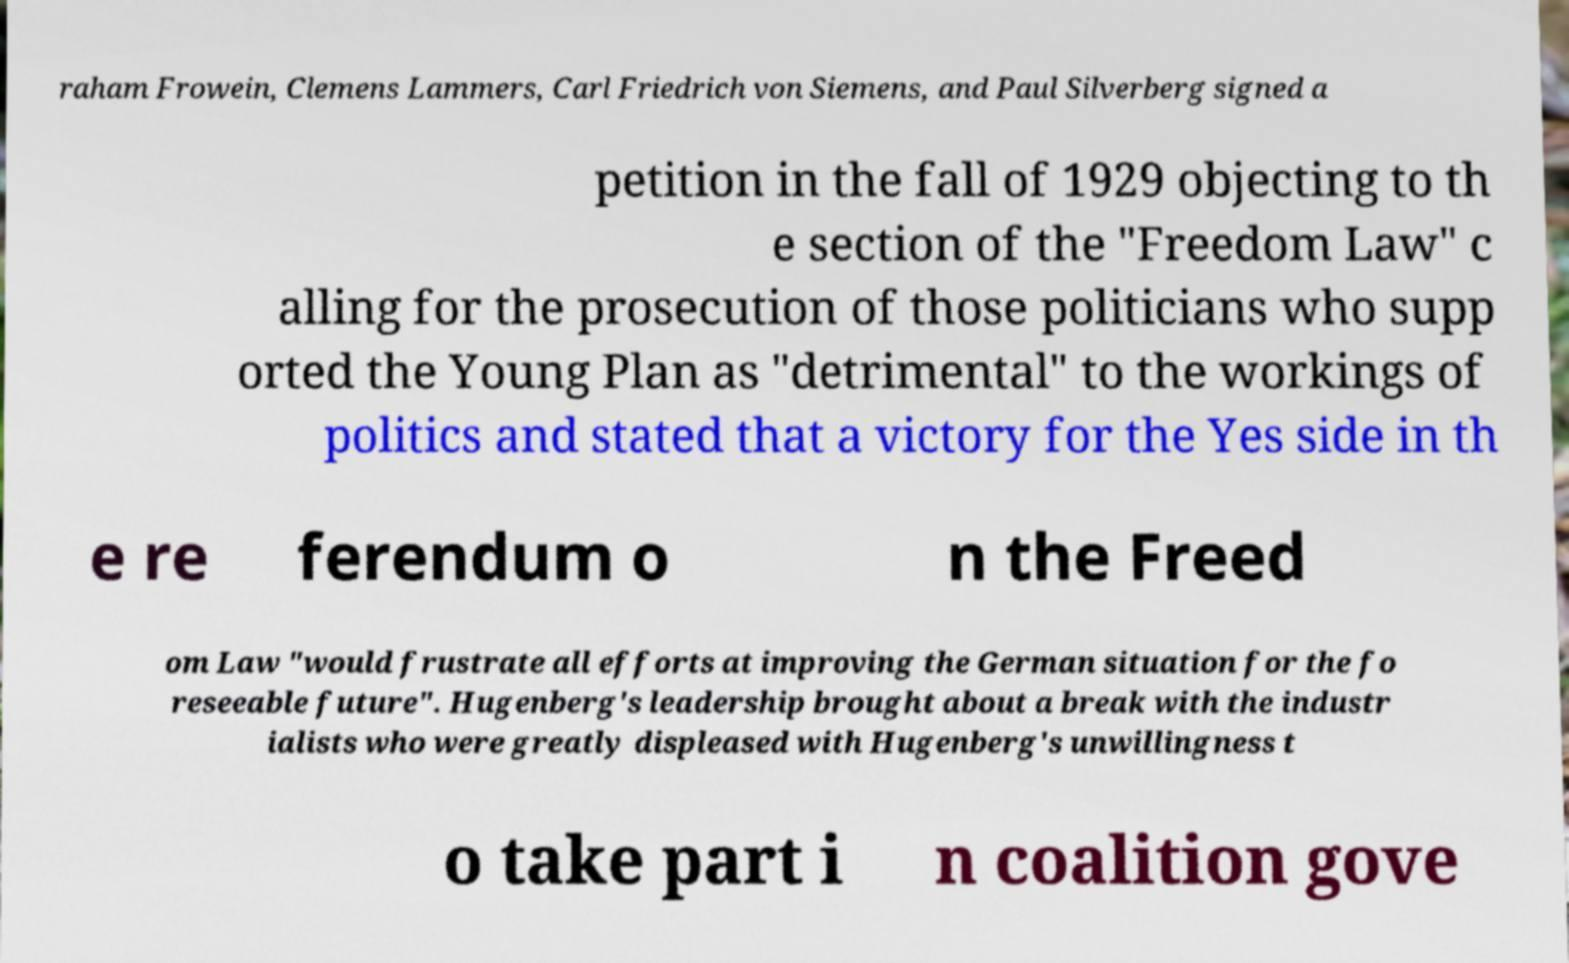Can you accurately transcribe the text from the provided image for me? raham Frowein, Clemens Lammers, Carl Friedrich von Siemens, and Paul Silverberg signed a petition in the fall of 1929 objecting to th e section of the "Freedom Law" c alling for the prosecution of those politicians who supp orted the Young Plan as "detrimental" to the workings of politics and stated that a victory for the Yes side in th e re ferendum o n the Freed om Law "would frustrate all efforts at improving the German situation for the fo reseeable future". Hugenberg's leadership brought about a break with the industr ialists who were greatly displeased with Hugenberg's unwillingness t o take part i n coalition gove 